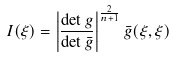Convert formula to latex. <formula><loc_0><loc_0><loc_500><loc_500>I ( \xi ) = \left | \frac { \det g } { \det \bar { g } } \right | ^ { \frac { 2 } { n + 1 } } \bar { g } ( \xi , \xi )</formula> 